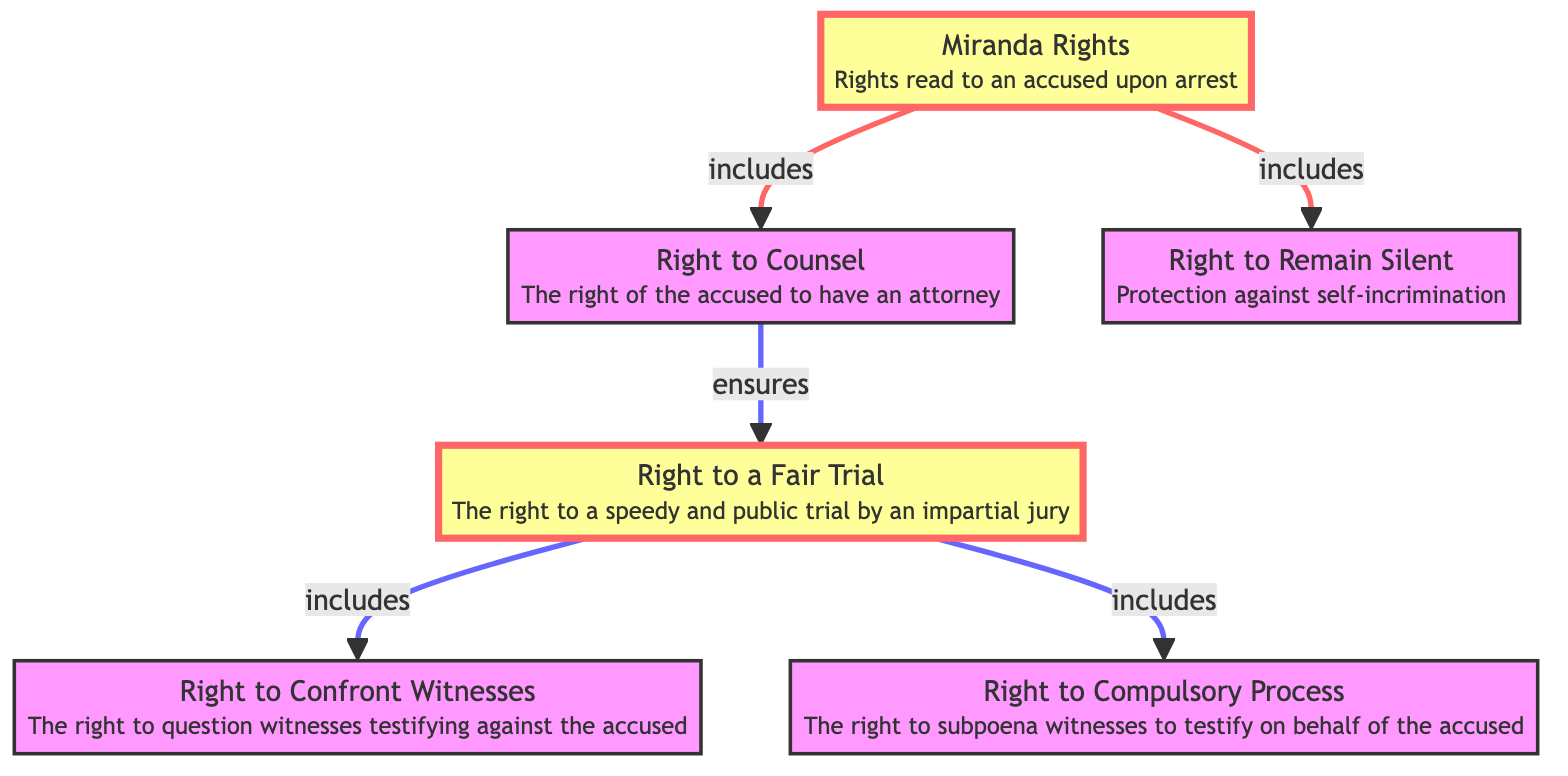What are the nodes in the diagram? The diagram contains six nodes: Miranda Rights, Right to Counsel, Right to Remain Silent, Right to a Fair Trial, Right to Confront Witnesses, and Right to Compulsory Process.
Answer: Miranda Rights, Right to Counsel, Right to Remain Silent, Right to a Fair Trial, Right to Confront Witnesses, Right to Compulsory Process How many edges are there in the diagram? The diagram contains five edges connecting the nodes, which illustrate the relationships between the rights of the accused.
Answer: 5 What does the Right to Counsel ensure? The Right to Counsel ensures the Right to a Fair Trial according to the relationship between those nodes in the diagram.
Answer: Right to a Fair Trial Which rights are included in the Miranda Rights? The Miranda Rights include the Right to Remain Silent and the Right to Counsel as shown by the edges leading from Miranda Rights to these two nodes.
Answer: Right to Remain Silent, Right to Counsel What is the relationship between Right to Fair Trial and Right to Confront Witnesses? The Right to Fair Trial includes the Right to Confront Witnesses, indicating that this right is part of what constitutes a fair trial.
Answer: includes What right provides protection against self-incrimination? The Right to Remain Silent provides protection against self-incrimination, as it is directly labeled in the diagram.
Answer: Right to Remain Silent Which nodes are highlighted in the diagram? The highlighted nodes in the diagram are Miranda Rights and Right to a Fair Trial, indicating their importance in the context of the rights of the accused.
Answer: Miranda Rights, Right to a Fair Trial What does the Right to Compulsory Process allow? The Right to Compulsory Process allows the accused to subpoena witnesses to testify on their behalf, as indicated in the description of that node.
Answer: subpoena witnesses How does the Right to Counsel relate to the Right to Confront Witnesses? The Right to Counsel indirectly supports the Right to Confront Witnesses by ensuring the accused has legal representation, which aids in questioning witnesses during a trial.
Answer: indirectly supports 